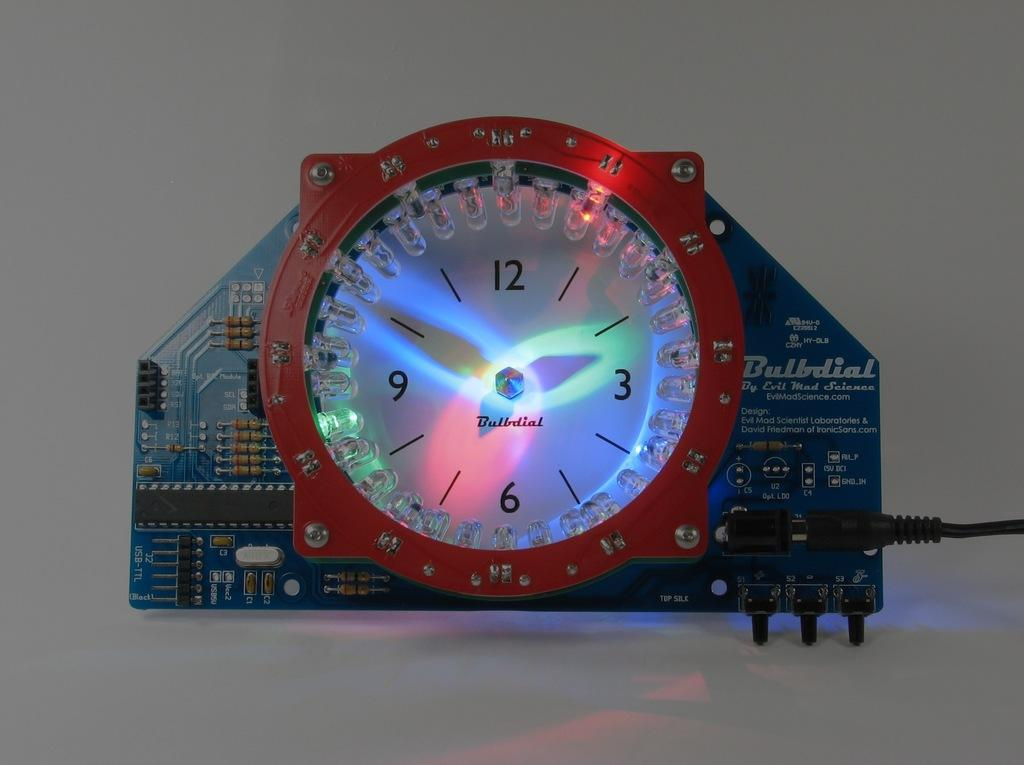<image>
Present a compact description of the photo's key features. A red and white bulbdial clock reads two fifty. 